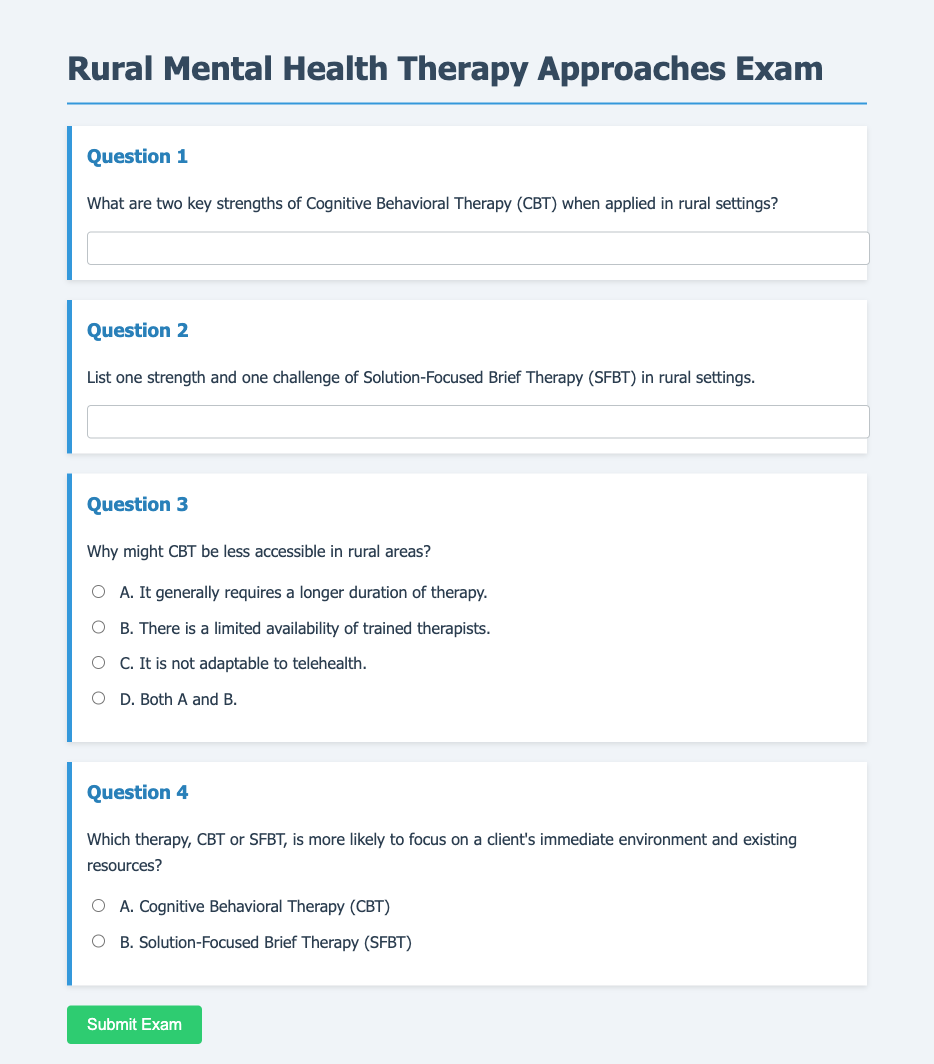What are two key strengths of Cognitive Behavioral Therapy? The question asks for specific strengths mentioned in the document about CBT in rural settings.
Answer: Strengths of CBT What is one strength and one challenge of Solution-Focused Brief Therapy? This question requires extracting one strength and one challenge mentioned for SFBT in rural settings.
Answer: One strength and one challenge Why is CBT less accessible in rural areas? This question asks for reasons provided in the document about the accessibility of CBT in rural areas.
Answer: Limited availability of trained therapists Which therapy focuses on a client's immediate environment? The question is asking about the therapy that emphasizes resources and environment based on the document.
Answer: Solution-Focused Brief Therapy What is the document type discussed? The document presents information in an exam format specifically addressing therapeutic approaches in rural mental health.
Answer: Exam 